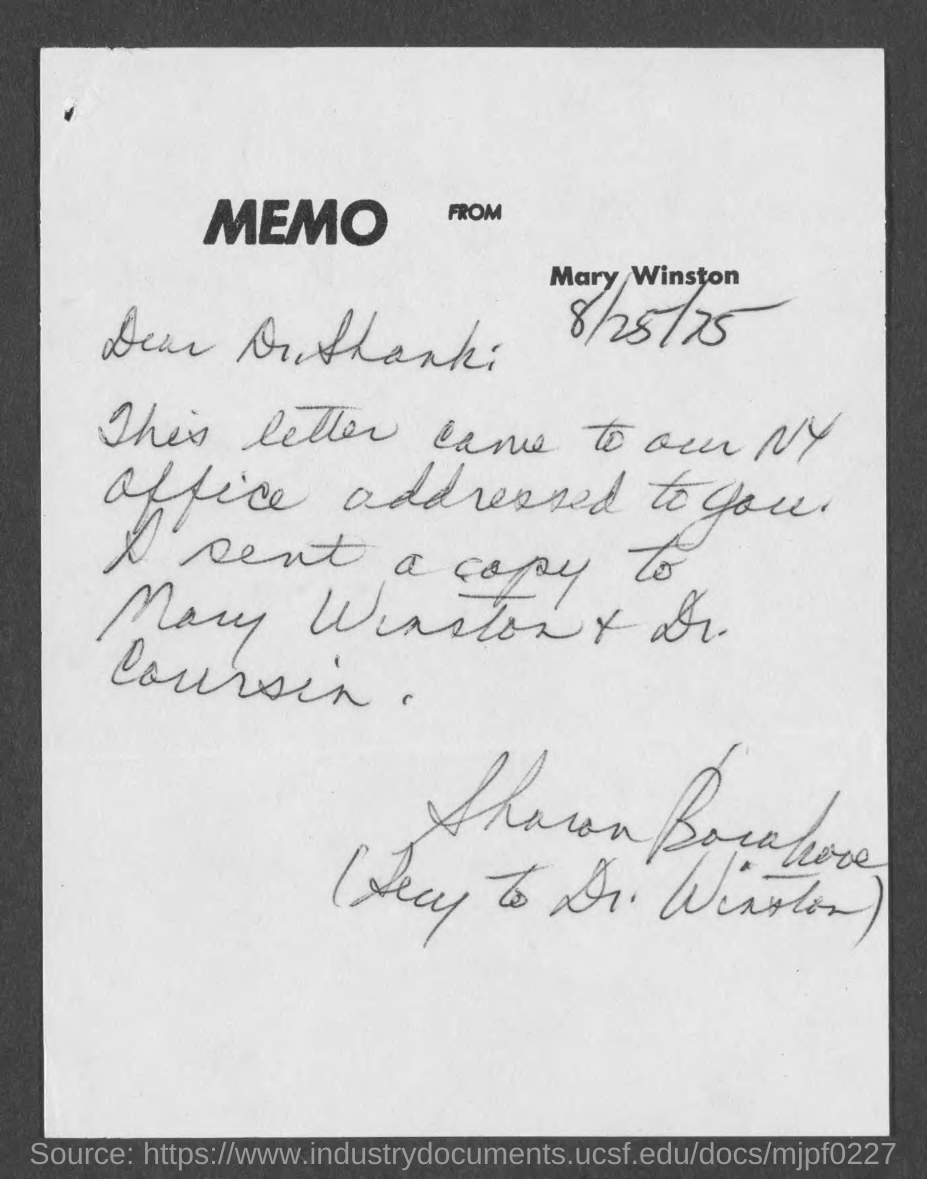Identify some key points in this picture. The document is dated August 25, 1975. This documentation is a memo. The memo is from Mary Winston. 